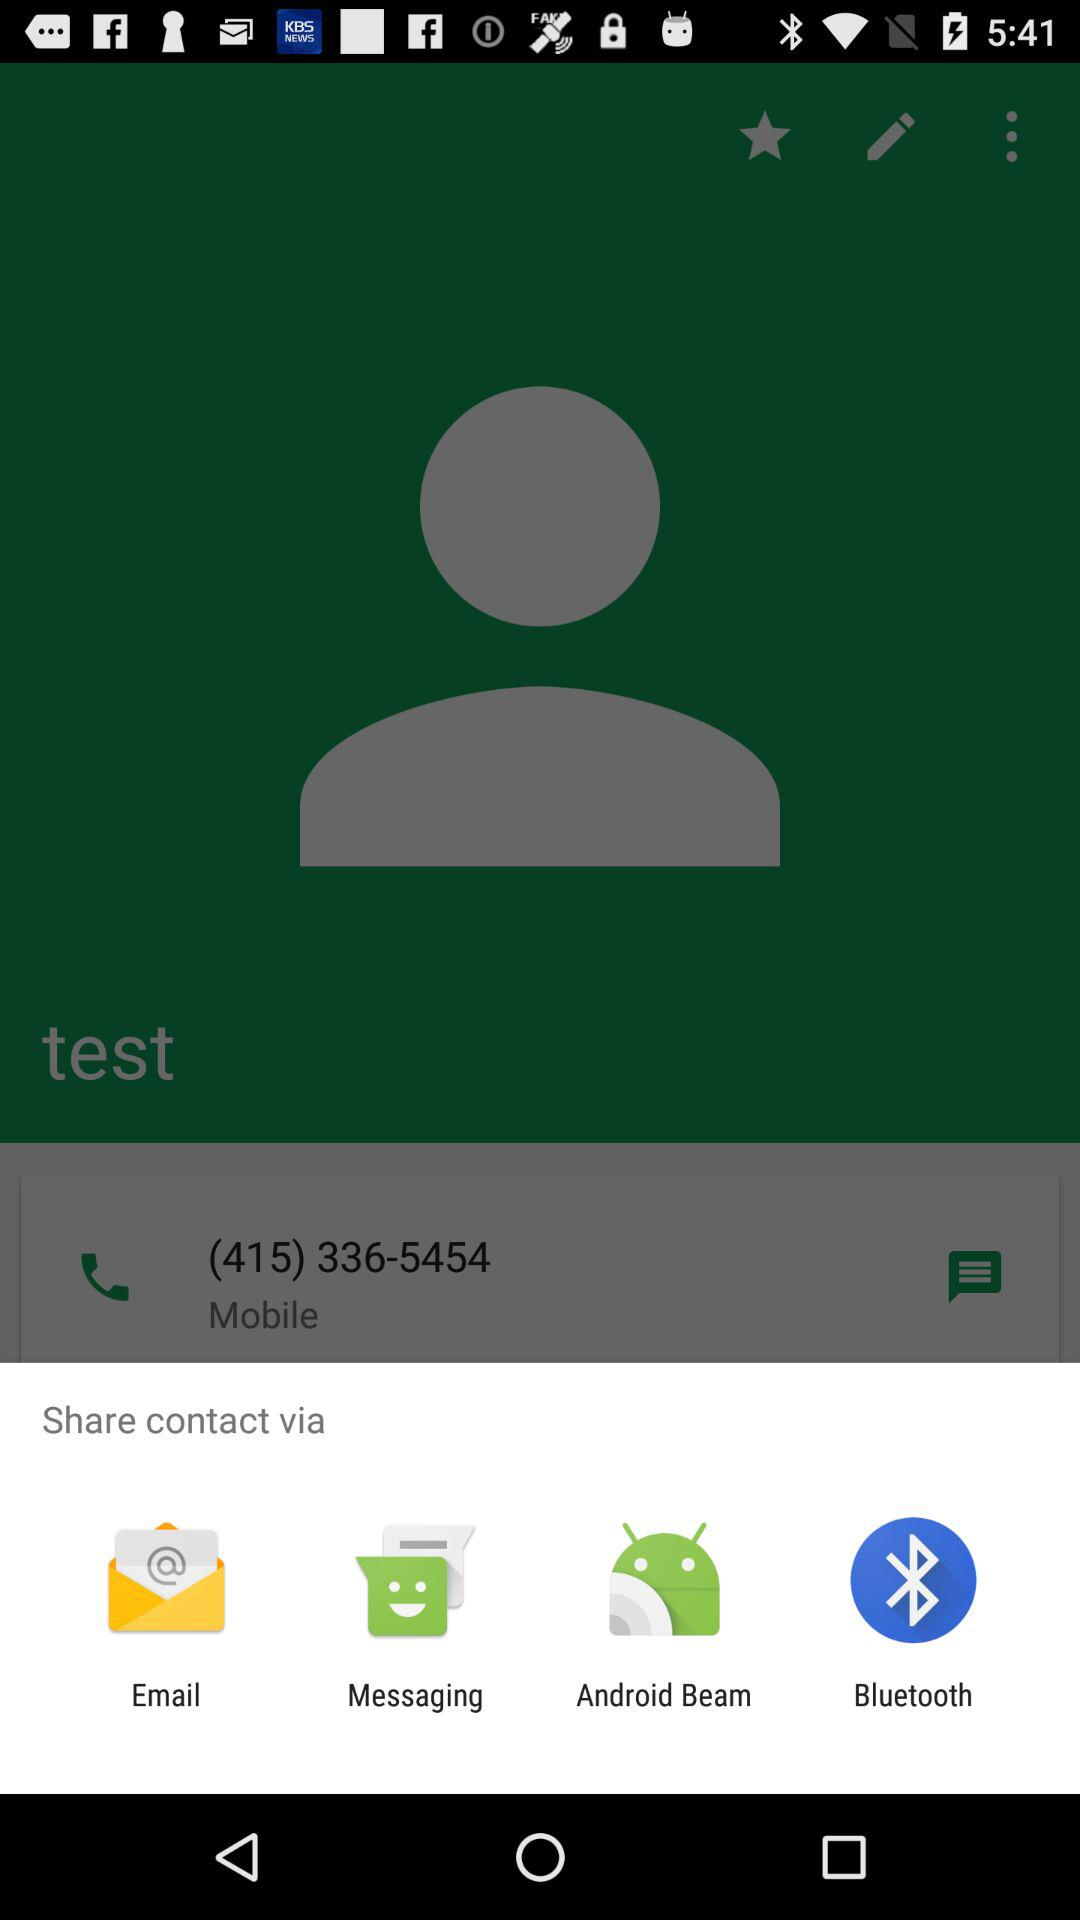How many items are in the share menu?
Answer the question using a single word or phrase. 4 